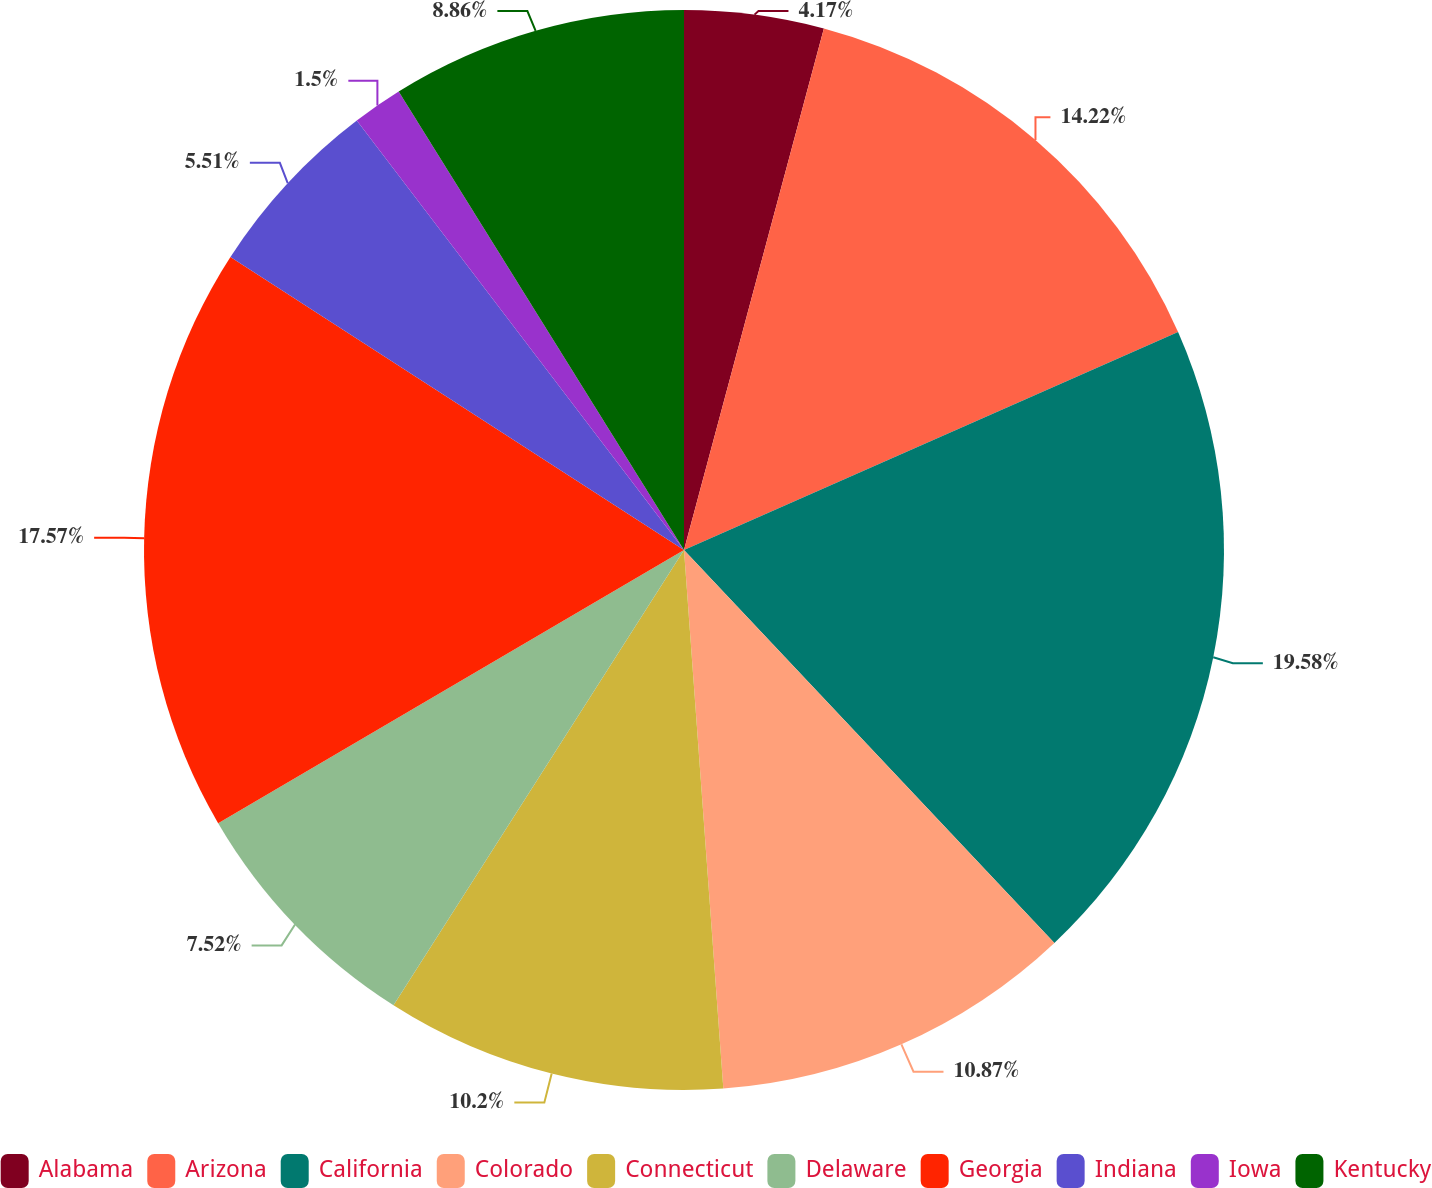<chart> <loc_0><loc_0><loc_500><loc_500><pie_chart><fcel>Alabama<fcel>Arizona<fcel>California<fcel>Colorado<fcel>Connecticut<fcel>Delaware<fcel>Georgia<fcel>Indiana<fcel>Iowa<fcel>Kentucky<nl><fcel>4.17%<fcel>14.22%<fcel>19.58%<fcel>10.87%<fcel>10.2%<fcel>7.52%<fcel>17.57%<fcel>5.51%<fcel>1.5%<fcel>8.86%<nl></chart> 